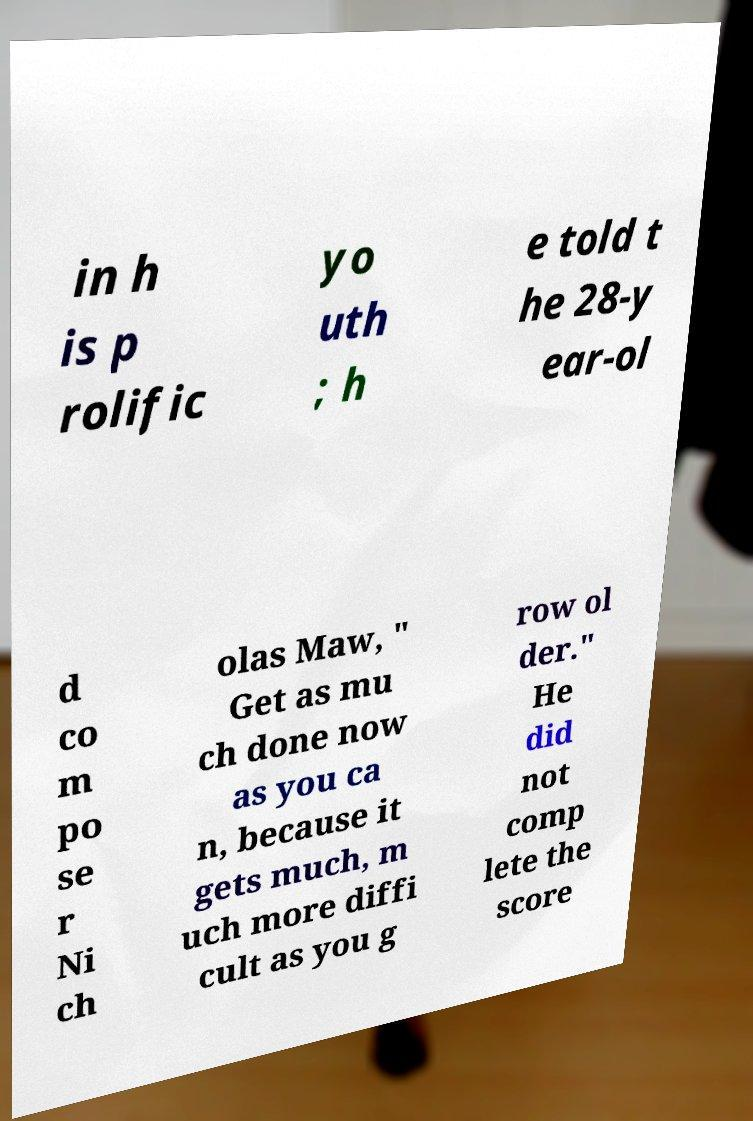What messages or text are displayed in this image? I need them in a readable, typed format. in h is p rolific yo uth ; h e told t he 28-y ear-ol d co m po se r Ni ch olas Maw, " Get as mu ch done now as you ca n, because it gets much, m uch more diffi cult as you g row ol der." He did not comp lete the score 